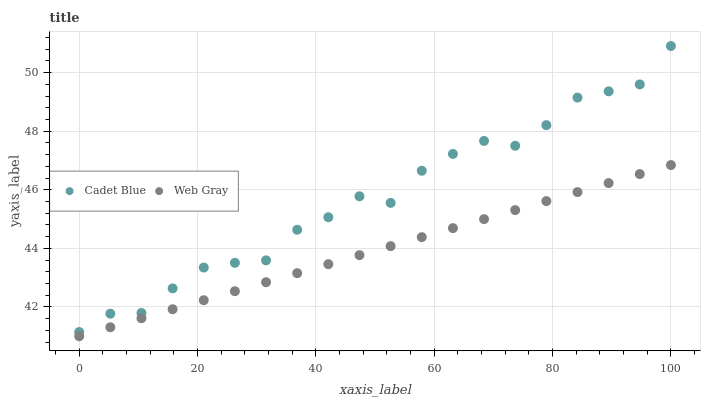Does Web Gray have the minimum area under the curve?
Answer yes or no. Yes. Does Cadet Blue have the maximum area under the curve?
Answer yes or no. Yes. Does Web Gray have the maximum area under the curve?
Answer yes or no. No. Is Web Gray the smoothest?
Answer yes or no. Yes. Is Cadet Blue the roughest?
Answer yes or no. Yes. Is Web Gray the roughest?
Answer yes or no. No. Does Web Gray have the lowest value?
Answer yes or no. Yes. Does Cadet Blue have the highest value?
Answer yes or no. Yes. Does Web Gray have the highest value?
Answer yes or no. No. Is Web Gray less than Cadet Blue?
Answer yes or no. Yes. Is Cadet Blue greater than Web Gray?
Answer yes or no. Yes. Does Web Gray intersect Cadet Blue?
Answer yes or no. No. 